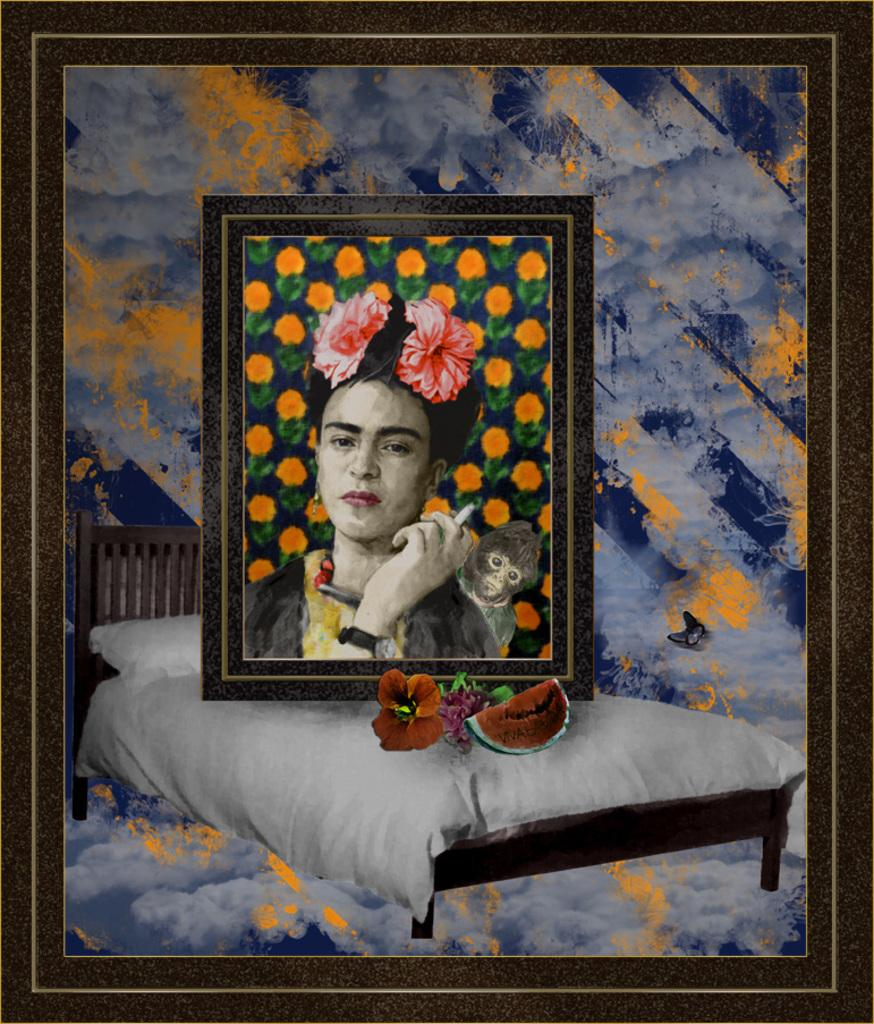What object can be seen in the image that typically holds a photograph? There is a photo frame in the image. Is there anything unusual about the photo frame? Yes, there is another frame on the photo frame. What is depicted in the second frame? The second frame contains a depiction of a woman and an animal on her back. What type of furniture is present in the image? There is a bed in the image. Can you describe any other items visible in the image? There are additional unspecified items visible in the image. Reasoning: Let' Let's think step by step in order to produce the conversation. We start by identifying the main subject of the image, which is the photo frame. Then, we describe the unique feature of the photo frame, which is the presence of another frame on it. Next, we focus on the content of the second frame, which is a woman and an animal. We then mention the presence of a bed, which is another piece of furniture in the image. Finally, we acknowledge that there are other unspecified items visible in the image, without going into detail about them. Absurd Question/Answer: Can you describe the fight between the patch and the theory in the image? There is no fight, patch, or theory present in the image. 